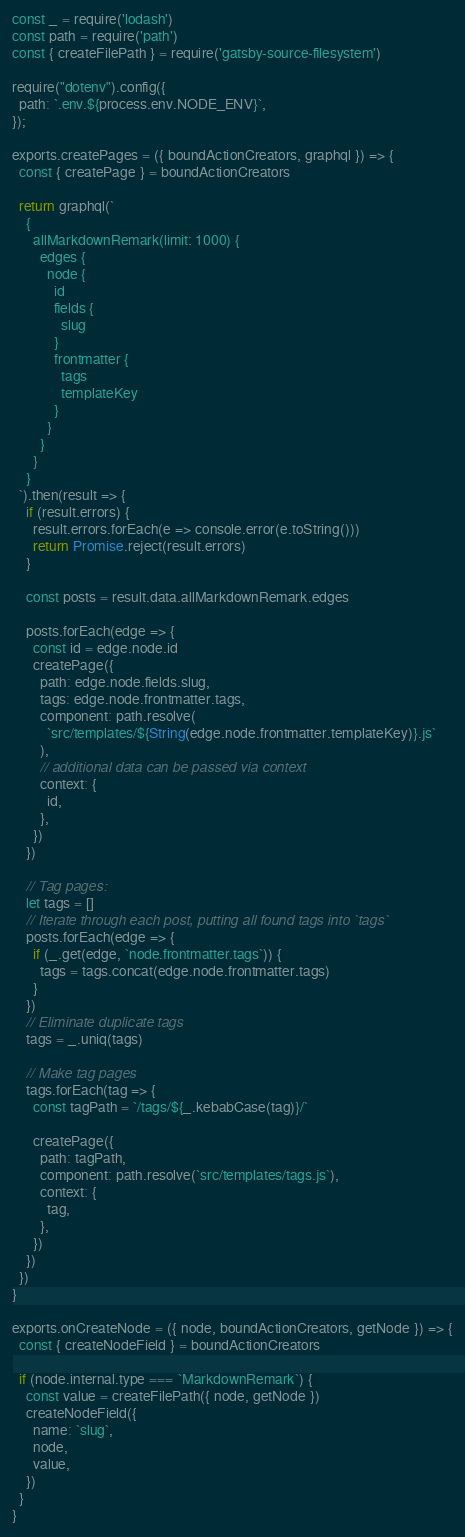Convert code to text. <code><loc_0><loc_0><loc_500><loc_500><_JavaScript_>const _ = require('lodash')
const path = require('path')
const { createFilePath } = require('gatsby-source-filesystem')

require("dotenv").config({
  path: `.env.${process.env.NODE_ENV}`,
});

exports.createPages = ({ boundActionCreators, graphql }) => {
  const { createPage } = boundActionCreators

  return graphql(`
    {
      allMarkdownRemark(limit: 1000) {
        edges {
          node {
            id
            fields {
              slug
            }
            frontmatter {
              tags
              templateKey
            }
          }
        }
      }
    } 
  `).then(result => {
    if (result.errors) {
      result.errors.forEach(e => console.error(e.toString()))
      return Promise.reject(result.errors)
    }

    const posts = result.data.allMarkdownRemark.edges

    posts.forEach(edge => {
      const id = edge.node.id
      createPage({
        path: edge.node.fields.slug,
        tags: edge.node.frontmatter.tags,
        component: path.resolve(
          `src/templates/${String(edge.node.frontmatter.templateKey)}.js`
        ),
        // additional data can be passed via context
        context: {
          id,
        },
      })
    })

    // Tag pages:
    let tags = []
    // Iterate through each post, putting all found tags into `tags`
    posts.forEach(edge => {
      if (_.get(edge, `node.frontmatter.tags`)) {
        tags = tags.concat(edge.node.frontmatter.tags)
      }
    })
    // Eliminate duplicate tags
    tags = _.uniq(tags)

    // Make tag pages
    tags.forEach(tag => {
      const tagPath = `/tags/${_.kebabCase(tag)}/`

      createPage({
        path: tagPath,
        component: path.resolve(`src/templates/tags.js`),
        context: {
          tag,
        },
      })
    })
  })
}

exports.onCreateNode = ({ node, boundActionCreators, getNode }) => {
  const { createNodeField } = boundActionCreators

  if (node.internal.type === `MarkdownRemark`) {
    const value = createFilePath({ node, getNode })
    createNodeField({
      name: `slug`,
      node,
      value,
    })
  }
}
</code> 